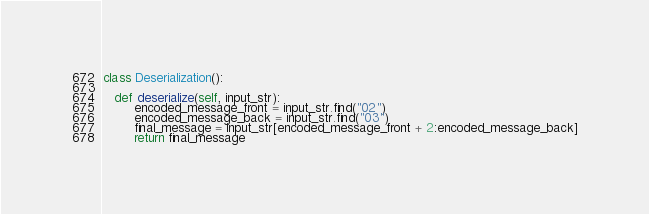Convert code to text. <code><loc_0><loc_0><loc_500><loc_500><_Python_>class Deserialization():

   def deserialize(self, input_str):
        encoded_message_front = input_str.find("02")
        encoded_message_back = input_str.find("03")
        final_message = input_str[encoded_message_front + 2:encoded_message_back]
        return final_message
</code> 